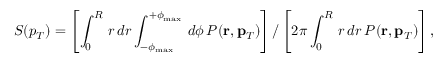Convert formula to latex. <formula><loc_0><loc_0><loc_500><loc_500>S ( p _ { T } ) = \left [ \int _ { 0 } ^ { R } \, r \, d r \int _ { - \phi _ { \max } } ^ { + \phi _ { \max } } \, d \phi \, P ( r , p _ { T } ) \right ] / \left [ 2 \pi \int _ { 0 } ^ { R } \, r \, d r \, P ( r , p _ { T } ) \right ] ,</formula> 